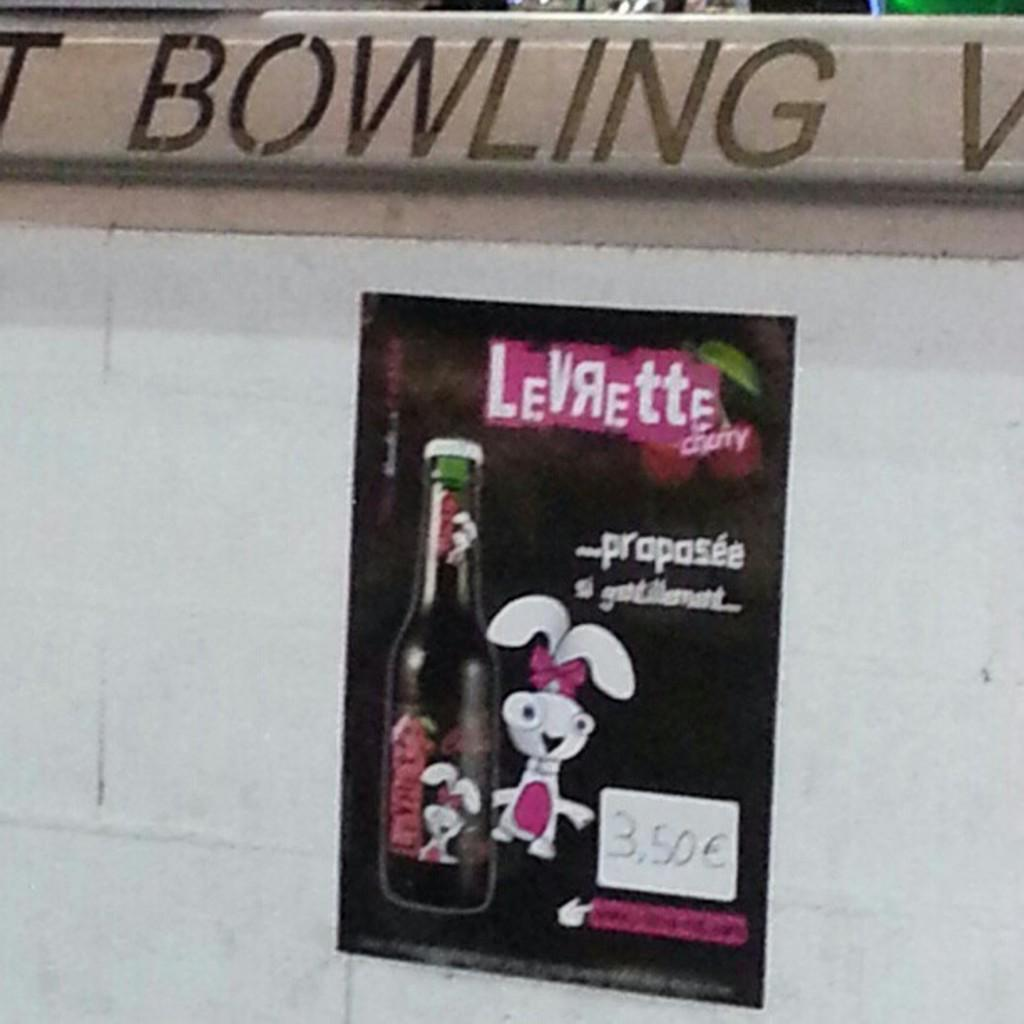<image>
Summarize the visual content of the image. The word bowling is above a poster that shows a white rabbit next to a bottle. 